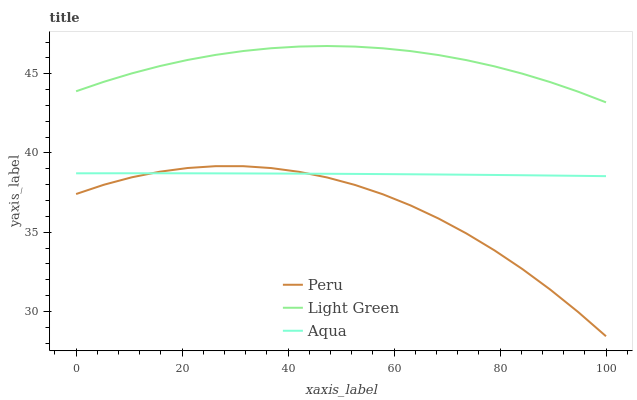Does Peru have the minimum area under the curve?
Answer yes or no. Yes. Does Light Green have the maximum area under the curve?
Answer yes or no. Yes. Does Light Green have the minimum area under the curve?
Answer yes or no. No. Does Peru have the maximum area under the curve?
Answer yes or no. No. Is Aqua the smoothest?
Answer yes or no. Yes. Is Peru the roughest?
Answer yes or no. Yes. Is Light Green the smoothest?
Answer yes or no. No. Is Light Green the roughest?
Answer yes or no. No. Does Peru have the lowest value?
Answer yes or no. Yes. Does Light Green have the lowest value?
Answer yes or no. No. Does Light Green have the highest value?
Answer yes or no. Yes. Does Peru have the highest value?
Answer yes or no. No. Is Aqua less than Light Green?
Answer yes or no. Yes. Is Light Green greater than Peru?
Answer yes or no. Yes. Does Aqua intersect Peru?
Answer yes or no. Yes. Is Aqua less than Peru?
Answer yes or no. No. Is Aqua greater than Peru?
Answer yes or no. No. Does Aqua intersect Light Green?
Answer yes or no. No. 